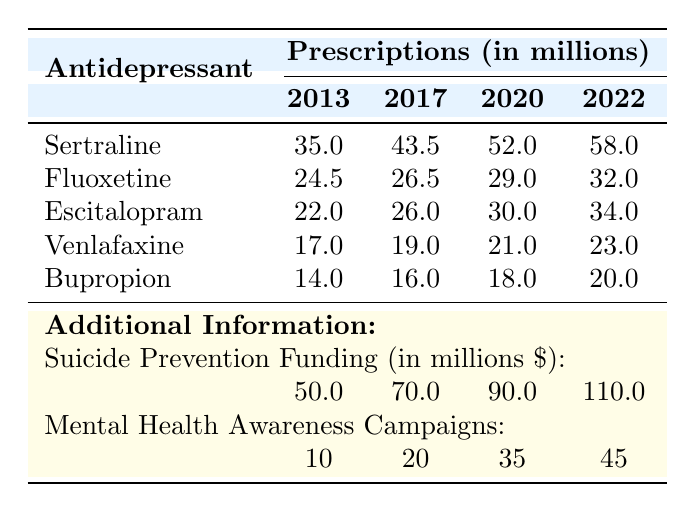What was the total number of prescriptions for Sertraline in 2022? The table shows that the number of prescriptions for Sertraline in 2022 is 58,000,000.
Answer: 58,000,000 Which antidepressant had the lowest number of prescriptions in 2013? The table indicates that Bupropion had the lowest prescriptions at 14,000,000 in 2013, compared to other antidepressants listed.
Answer: Bupropion What is the increase in prescriptions for Escitalopram from 2013 to 2022? The number of prescriptions for Escitalopram in 2013 was 22,000,000, and in 2022 it was 34,000,000. The increase is 34,000,000 - 22,000,000 = 12,000,000.
Answer: 12,000,000 What percentage increase in prescriptions did Fluoxetine experience from 2013 to 2022? Fluoxetine had 24,500,000 prescriptions in 2013 and 32,000,000 in 2022. The increase was 32,000,000 - 24,500,000 = 7,500,000. The percentage increase is (7,500,000 / 24,500,000) * 100 ≈ 30.61%.
Answer: 30.61% How many total prescriptions were made for all antidepressants in 2020? The total prescriptions for all antidepressants in 2020 can be calculated by summing their individual prescriptions: 52,000,000 (Sertraline) + 29,000,000 (Fluoxetine) + 30,000,000 (Escitalopram) + 21,000,000 (Venlafaxine) + 18,000,000 (Bupropion) = 150,000,000.
Answer: 150,000,000 Did the funding for suicide prevention increase each year from 2013 to 2022? The funding for suicide prevention starts at 50,000,000 in 2013 and increases to 110,000,000 in 2022, showing an increase every year.
Answer: Yes What is the ratio of prescriptions for Sertraline to Venlafaxine in 2022? In 2022, Sertraline had 58,000,000 prescriptions and Venlafaxine had 23,000,000 prescriptions. The ratio is 58,000,000 : 23,000,000, which simplifies to approximately 2.52 : 1.
Answer: 2.52 : 1 What is the average number of prescriptions for Antidepressants in 2017? The prescriptions for antidepressants in 2017 are: Sertraline (43,500,000), Fluoxetine (26,500,000), Escitalopram (26,000,000), Venlafaxine (19,000,000), Bupropion (16,000,000). The average is (43,500,000 + 26,500,000 + 26,000,000 + 19,000,000 + 16,000,000) / 5 = 26,000,000.
Answer: 26,000,000 How many more mental health awareness campaigns were conducted in 2022 compared to 2013? In 2013, there were 10 campaigns and in 2022, there were 45 campaigns. The difference is 45 - 10 = 35 campaigns.
Answer: 35 Which antidepressant had the highest growth rate over the decade? The growth rates can be calculated by the difference in prescriptions from 2013 to 2022 divided by the 2013 value for each antidepressant. For Sertraline, it's (58,000,000 - 35,000,000) / 35,000,000 ≈ 66.67%. For Fluoxetine, it's (32,000,000 - 24,500,000) / 24,500,000 ≈ 30.61%. For the others, similar calculations show that Sertraline had the highest growth rate.
Answer: Sertraline 